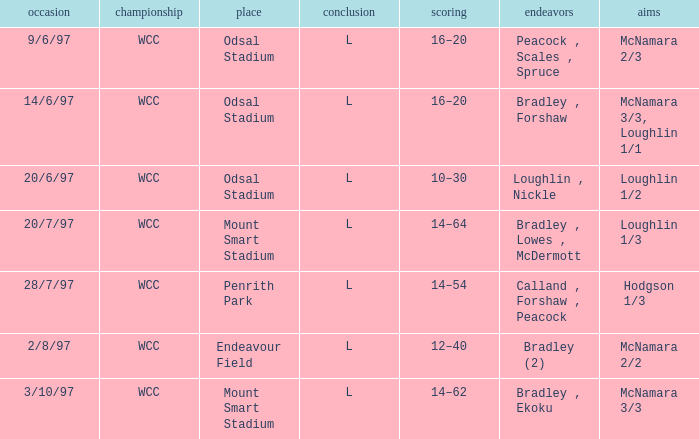What attempts were made on june 14, 1997? Bradley , Forshaw. 